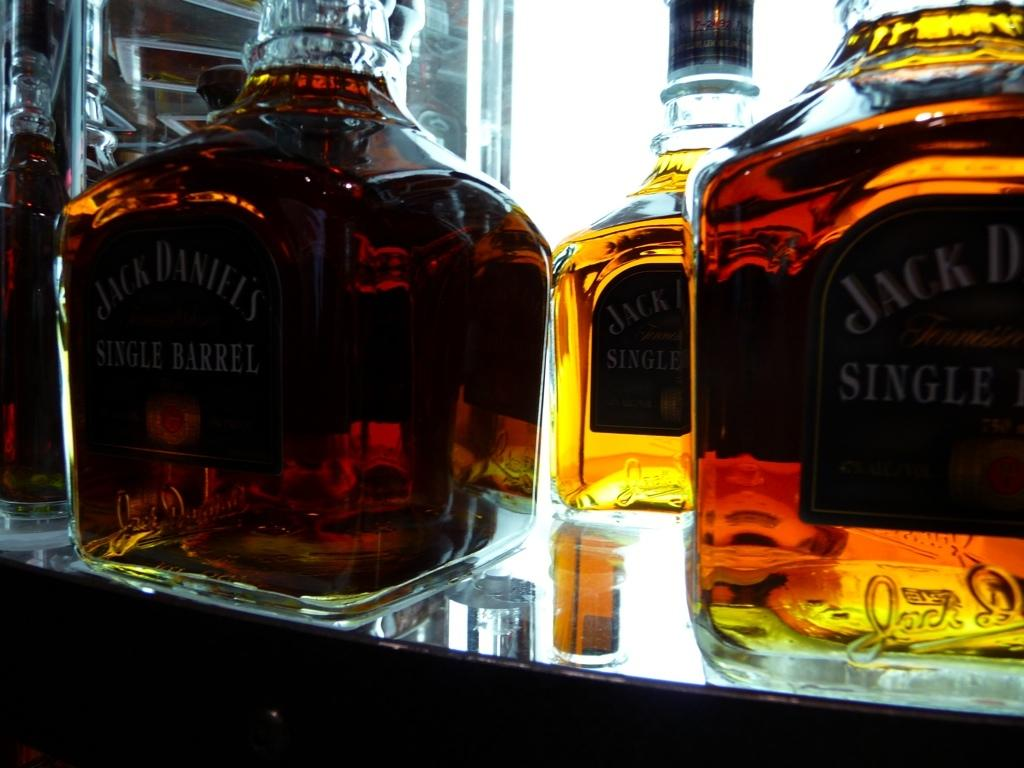Provide a one-sentence caption for the provided image. Three bottles of Jack Daniel's single barrel sitting on a glass table. 